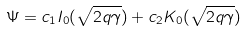<formula> <loc_0><loc_0><loc_500><loc_500>\Psi = c _ { 1 } I _ { 0 } ( \sqrt { 2 q \gamma } ) + c _ { 2 } K _ { 0 } ( \sqrt { 2 q \gamma } )</formula> 